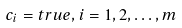<formula> <loc_0><loc_0><loc_500><loc_500>c _ { i } = t r u e , i = 1 , 2 , \dots , m</formula> 